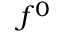<formula> <loc_0><loc_0><loc_500><loc_500>f ^ { 0 }</formula> 